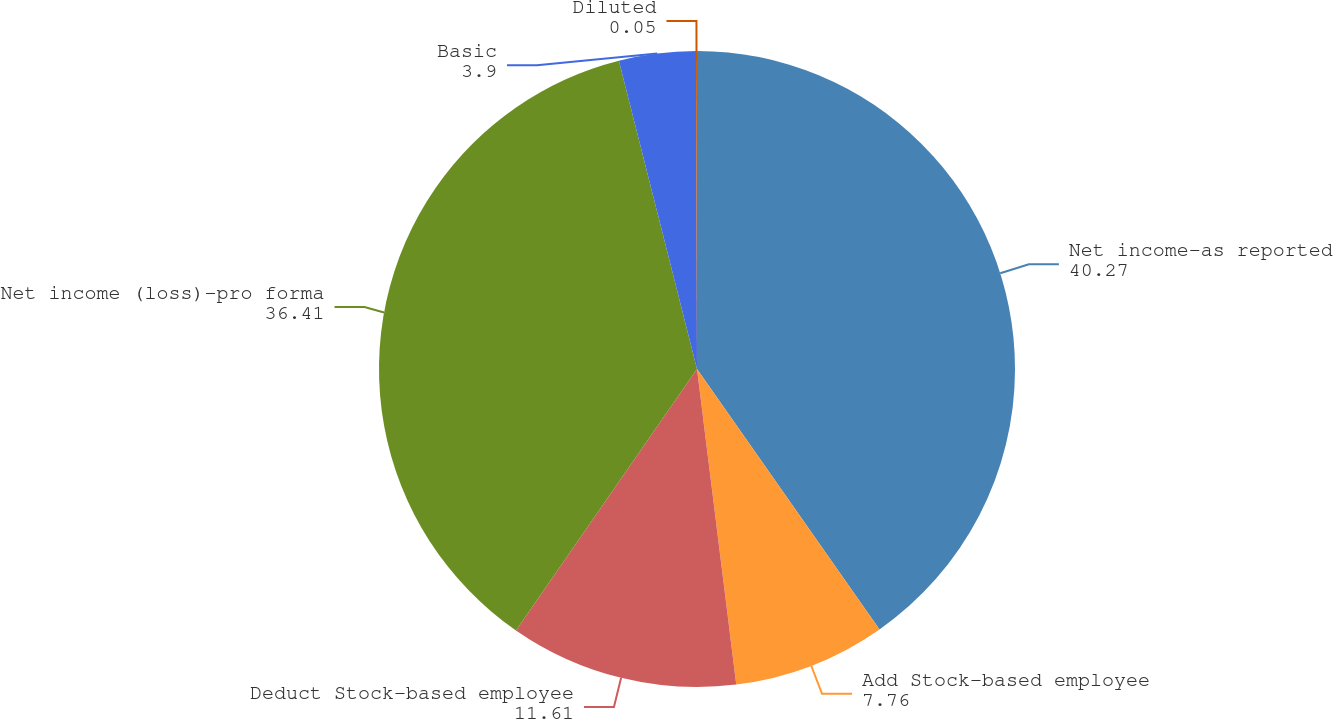Convert chart to OTSL. <chart><loc_0><loc_0><loc_500><loc_500><pie_chart><fcel>Net income-as reported<fcel>Add Stock-based employee<fcel>Deduct Stock-based employee<fcel>Net income (loss)-pro forma<fcel>Basic<fcel>Diluted<nl><fcel>40.27%<fcel>7.76%<fcel>11.61%<fcel>36.41%<fcel>3.9%<fcel>0.05%<nl></chart> 